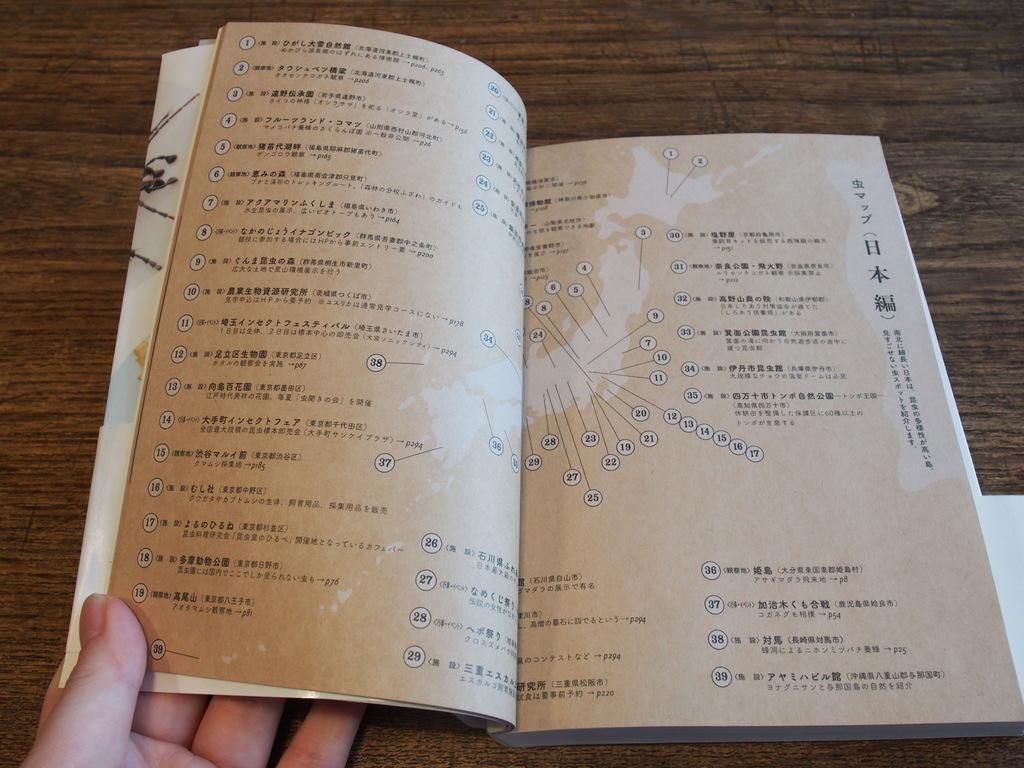How would you summarize this image in a sentence or two? In this image I can see a book,on the table and a person hand visible at the bottom which is holding a book. 